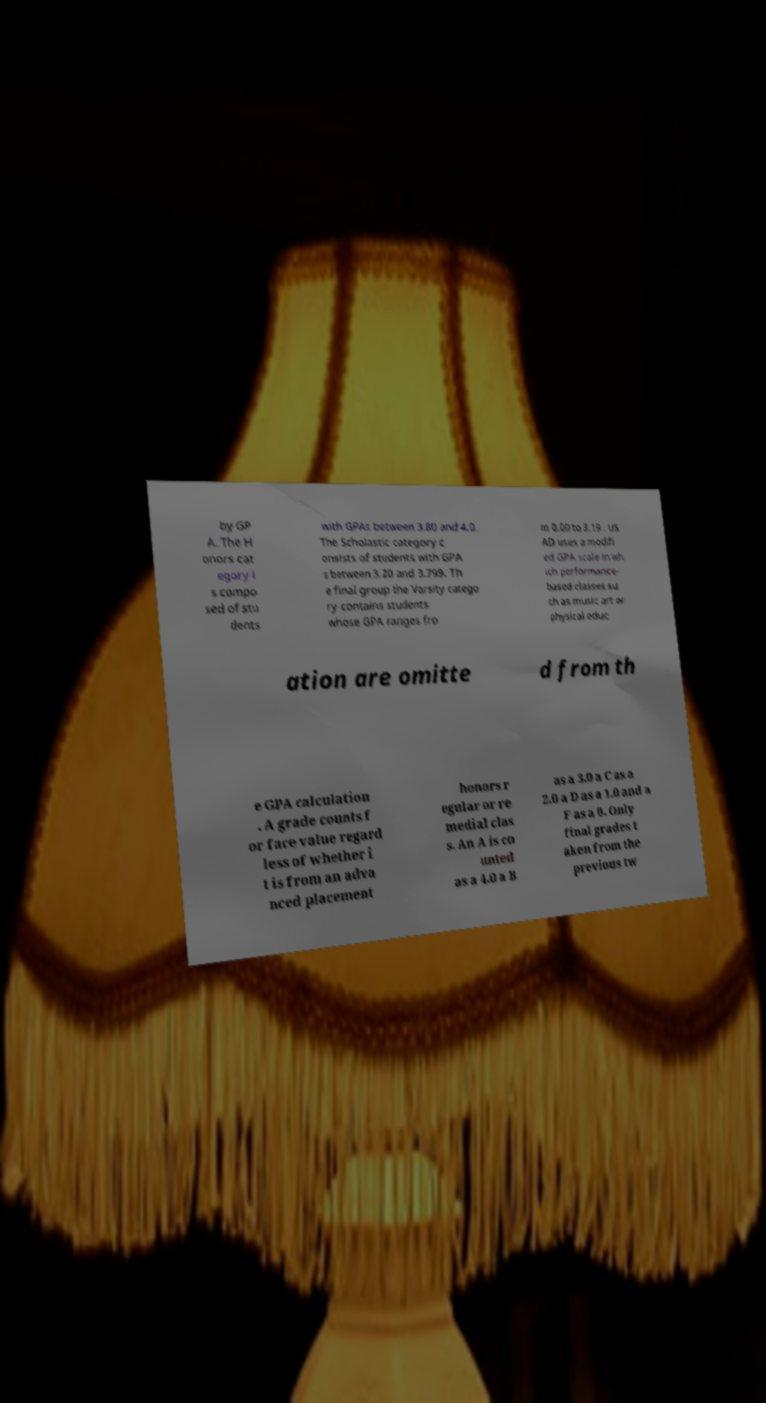Please identify and transcribe the text found in this image. by GP A. The H onors cat egory i s compo sed of stu dents with GPAs between 3.80 and 4.0. The Scholastic category c onsists of students with GPA s between 3.20 and 3.799. Th e final group the Varsity catego ry contains students whose GPA ranges fro m 0.00 to 3.19 . US AD uses a modifi ed GPA scale in wh ich performance- based classes su ch as music art or physical educ ation are omitte d from th e GPA calculation . A grade counts f or face value regard less of whether i t is from an adva nced placement honors r egular or re medial clas s. An A is co unted as a 4.0 a B as a 3.0 a C as a 2.0 a D as a 1.0 and a F as a 0. Only final grades t aken from the previous tw 